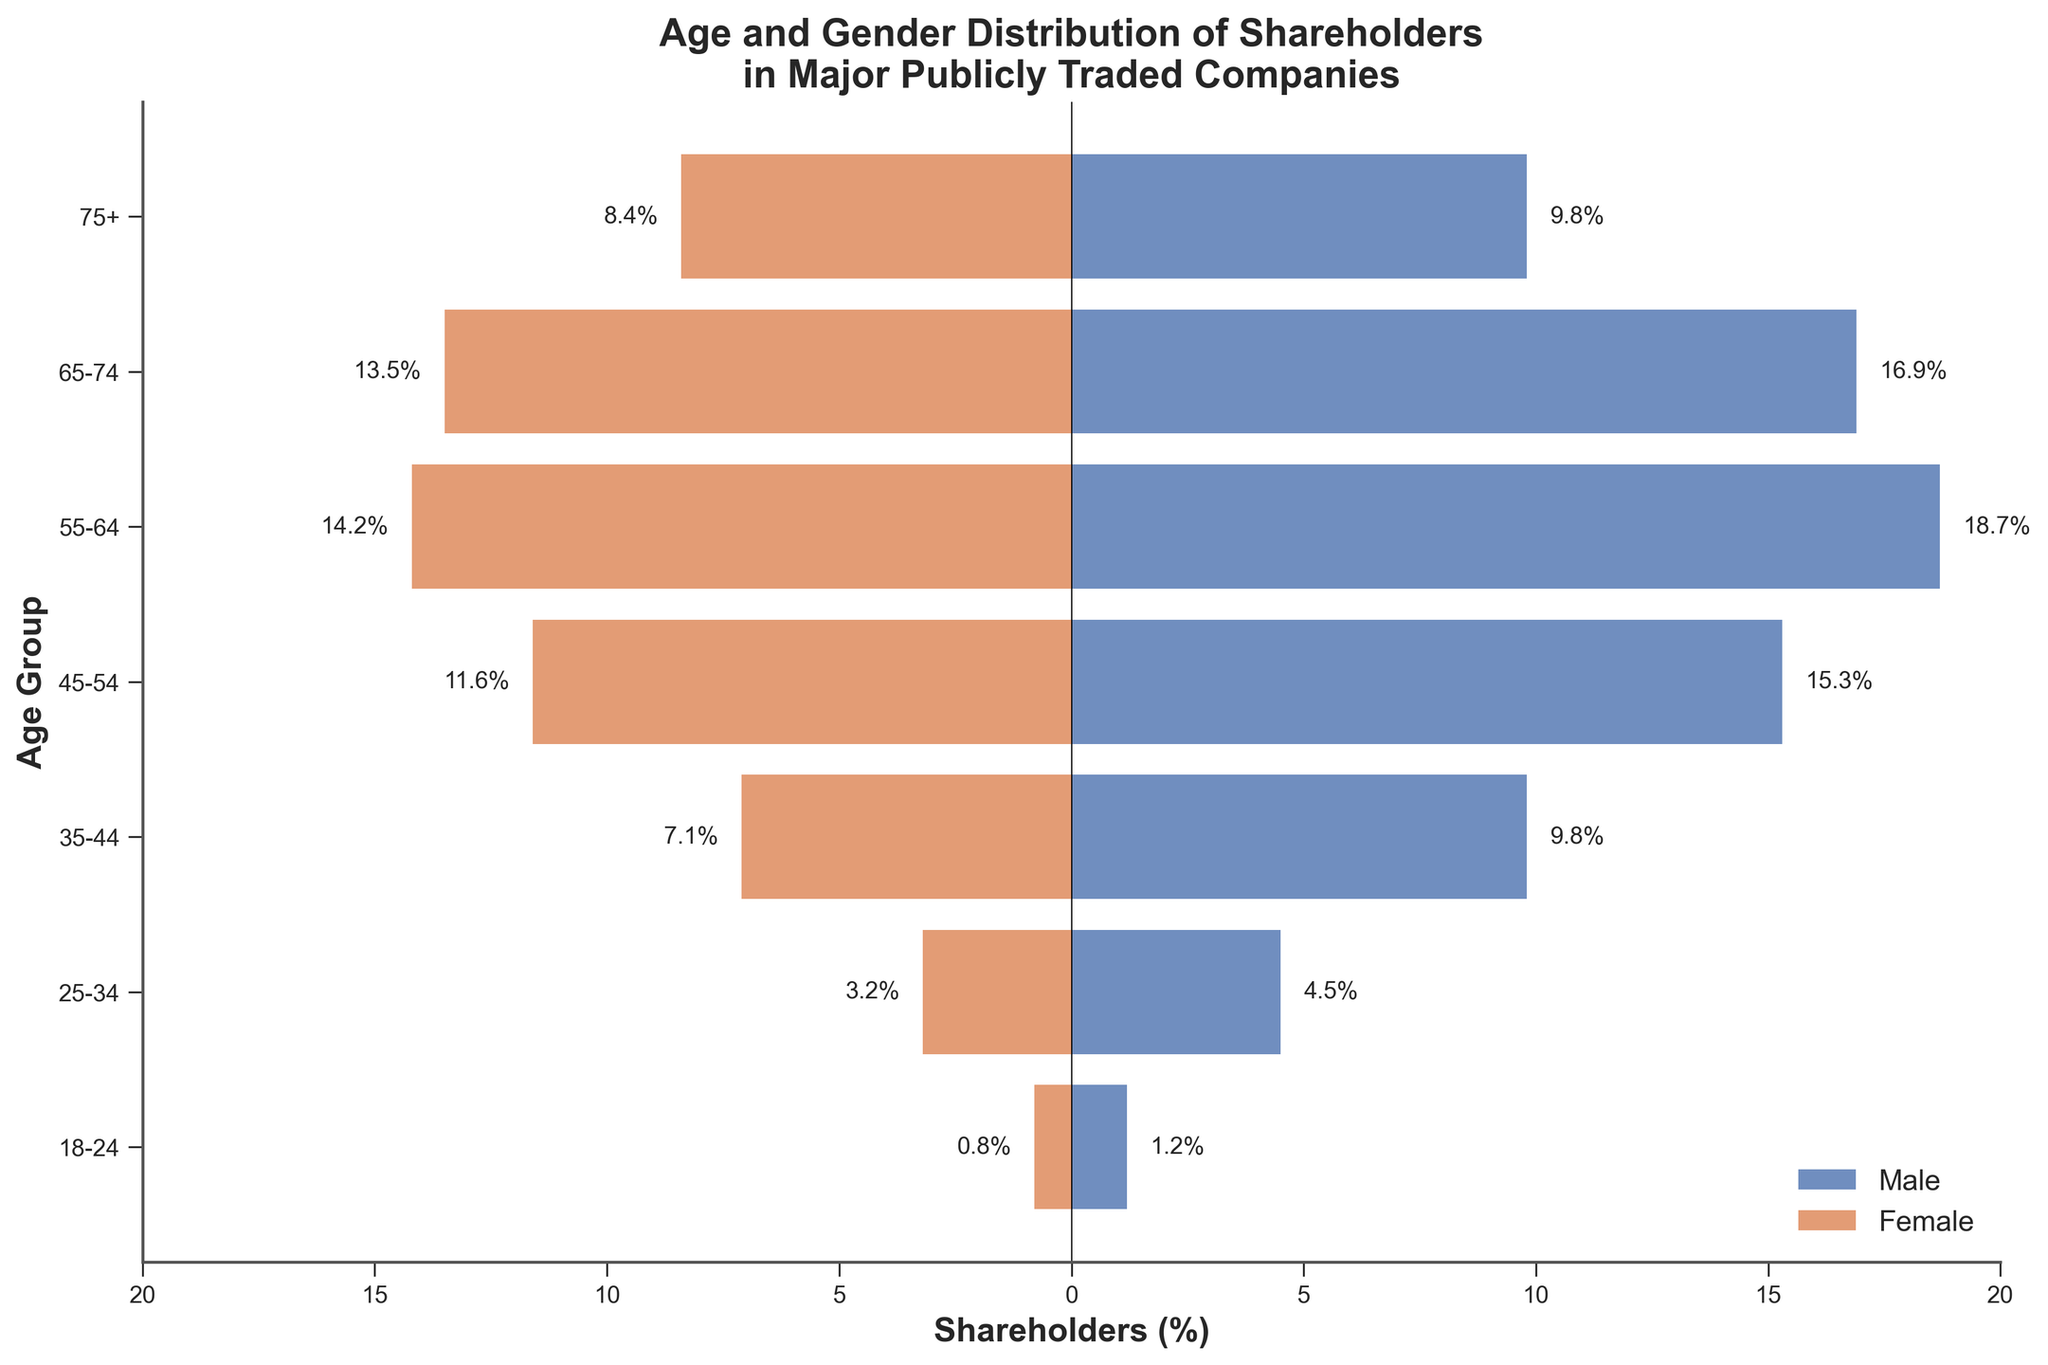What's the title of the figure? The title is typically found at the top of the figure. It gives a concise description of what the figure represents: "Age and Gender Distribution of Shareholders in Major Publicly Traded Companies."
Answer: Age and Gender Distribution of Shareholders in Major Publicly Traded Companies What are the two colors used in the bars and what do they represent? The figure legend indicates that the colors represent different genders. The blue bars represent male shareholders, and the orange bars represent female shareholders.
Answer: Blue for male, orange for female Which age group has the highest percentage of male shareholders? By looking at the horizontal bars, the longest blue bar represents the group with the highest percentage of male shareholders. This is the 55-64 age group with 18.7%.
Answer: 55-64 What is the total percentage of shareholders in the 65-74 age group (both male and female)? Adding the percentages of male and female shareholders in the 65-74 age group: 16.9% + 13.5% = 30.4%.
Answer: 30.4% How does the percentage of female shareholders in the 45-54 age group compare to the percentage in the 18-24 age group? The figure shows the percentage of female shareholders in the 45-54 age group as 11.6% and in the 18-24 age group as 0.8%. 11.6% is significantly higher than 0.8%.
Answer: 45-54 is higher What is the combined percentage of male and female shareholders who are 75+ years old? Combine the percentages of male and female shareholders in the 75+ age group: 9.8% + 8.4% = 18.2%.
Answer: 18.2% In terms of gender, is there a noticeable trend in shareholder percentages as age increases? Observing the bars for both genders, both male and female shareholder percentages peak at 55-64 and then start to decline. This indicates a trend where middle-aged individuals have higher percentages of shareholders.
Answer: Middle-aged have higher percentages Which age group has the smallest gender gap in percentage terms? To find the smallest gender gap, look at the difference in percentages between male and female shareholders for each age group. The smallest difference is for the 75+ group: 9.8% male - 8.4% female = 1.4%.
Answer: 75+ Which age group shows the largest discrepancy between male and female shareholder percentages? The 55-64 age group has the largest difference between male and female shareholder percentages: 18.7% - 14.2% = 4.5%.
Answer: 55-64 